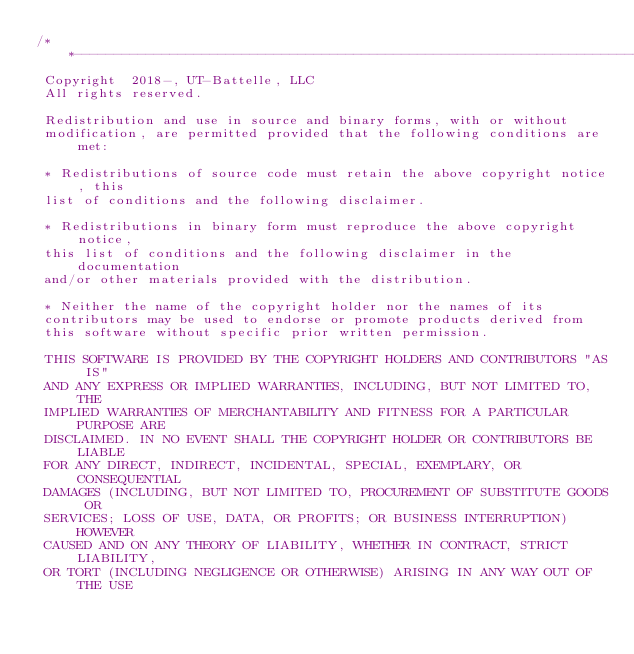Convert code to text. <code><loc_0><loc_0><loc_500><loc_500><_C++_>/**----------------------------------------------------------------------------
 Copyright  2018-, UT-Battelle, LLC
 All rights reserved.

 Redistribution and use in source and binary forms, with or without
 modification, are permitted provided that the following conditions are met:

 * Redistributions of source code must retain the above copyright notice, this
 list of conditions and the following disclaimer.

 * Redistributions in binary form must reproduce the above copyright notice,
 this list of conditions and the following disclaimer in the documentation
 and/or other materials provided with the distribution.

 * Neither the name of the copyright holder nor the names of its
 contributors may be used to endorse or promote products derived from
 this software without specific prior written permission.

 THIS SOFTWARE IS PROVIDED BY THE COPYRIGHT HOLDERS AND CONTRIBUTORS "AS IS"
 AND ANY EXPRESS OR IMPLIED WARRANTIES, INCLUDING, BUT NOT LIMITED TO, THE
 IMPLIED WARRANTIES OF MERCHANTABILITY AND FITNESS FOR A PARTICULAR PURPOSE ARE
 DISCLAIMED. IN NO EVENT SHALL THE COPYRIGHT HOLDER OR CONTRIBUTORS BE LIABLE
 FOR ANY DIRECT, INDIRECT, INCIDENTAL, SPECIAL, EXEMPLARY, OR CONSEQUENTIAL
 DAMAGES (INCLUDING, BUT NOT LIMITED TO, PROCUREMENT OF SUBSTITUTE GOODS OR
 SERVICES; LOSS OF USE, DATA, OR PROFITS; OR BUSINESS INTERRUPTION) HOWEVER
 CAUSED AND ON ANY THEORY OF LIABILITY, WHETHER IN CONTRACT, STRICT LIABILITY,
 OR TORT (INCLUDING NEGLIGENCE OR OTHERWISE) ARISING IN ANY WAY OUT OF THE USE</code> 